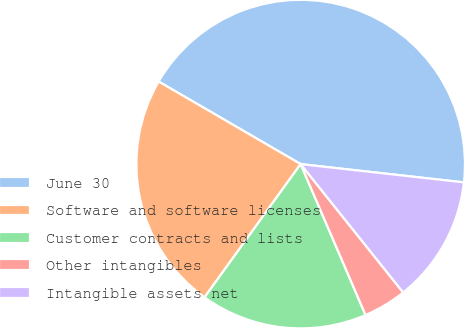Convert chart. <chart><loc_0><loc_0><loc_500><loc_500><pie_chart><fcel>June 30<fcel>Software and software licenses<fcel>Customer contracts and lists<fcel>Other intangibles<fcel>Intangible assets net<nl><fcel>43.39%<fcel>23.43%<fcel>16.41%<fcel>4.26%<fcel>12.5%<nl></chart> 